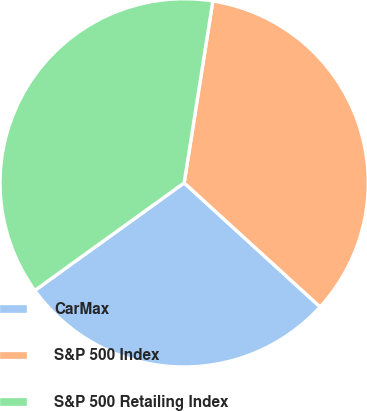<chart> <loc_0><loc_0><loc_500><loc_500><pie_chart><fcel>CarMax<fcel>S&P 500 Index<fcel>S&P 500 Retailing Index<nl><fcel>28.29%<fcel>34.28%<fcel>37.43%<nl></chart> 